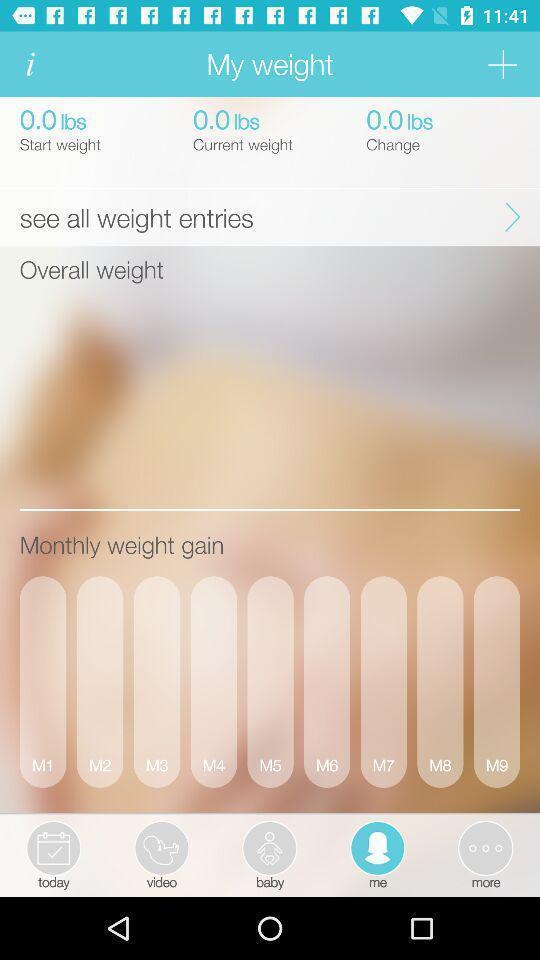What can you discern from this picture? Weight page of a pregnancy tracker app. 